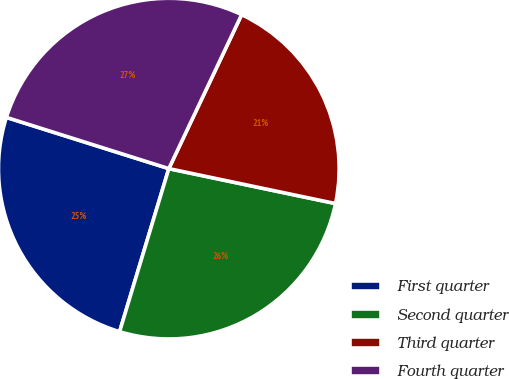Convert chart. <chart><loc_0><loc_0><loc_500><loc_500><pie_chart><fcel>First quarter<fcel>Second quarter<fcel>Third quarter<fcel>Fourth quarter<nl><fcel>25.2%<fcel>26.38%<fcel>21.26%<fcel>27.17%<nl></chart> 